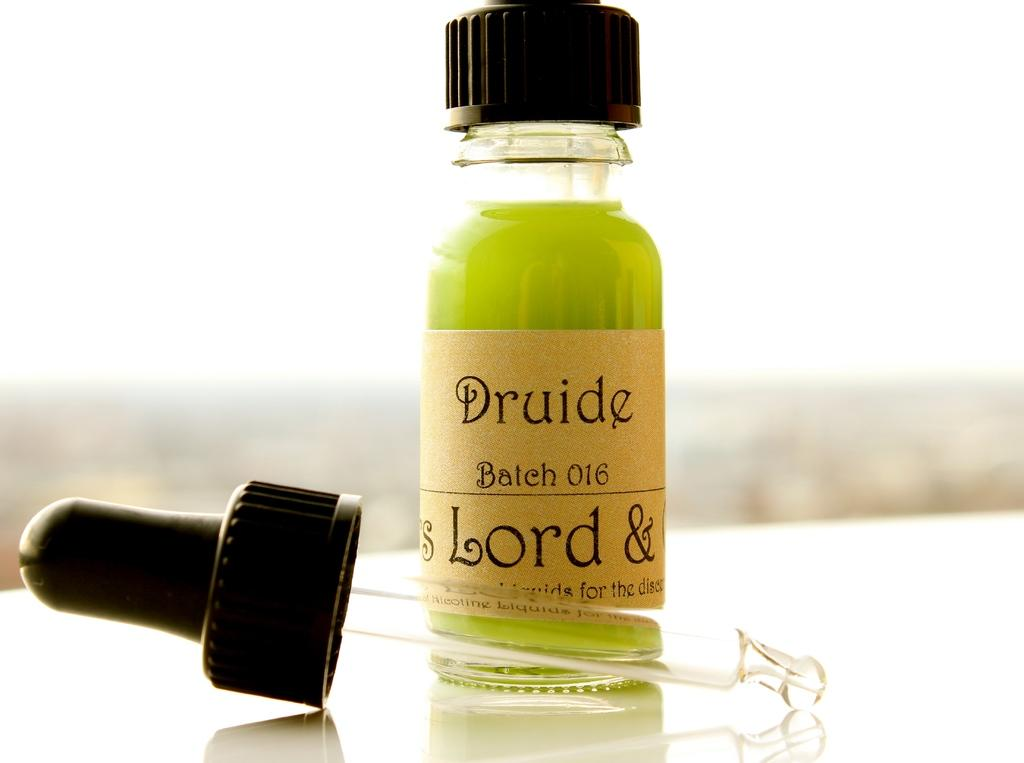What object is present in the image that is typically used for holding liquids? There is a bottle in the image. What is written on the bottle? The bottle is labelled as 'DRUIDE'. Where is the bottle located in the image? The bottle is placed on a table. What else can be seen on the table in the image? There is a black color cap on the table. Can you see any muscles in the image? There are no muscles visible in the image. Is there a lake present in the image? There is no lake present in the image. 